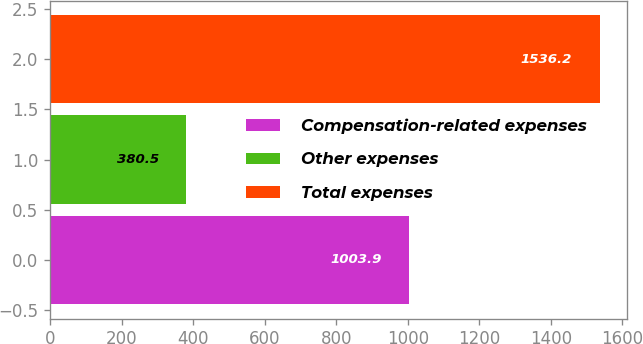Convert chart. <chart><loc_0><loc_0><loc_500><loc_500><bar_chart><fcel>Compensation-related expenses<fcel>Other expenses<fcel>Total expenses<nl><fcel>1003.9<fcel>380.5<fcel>1536.2<nl></chart> 